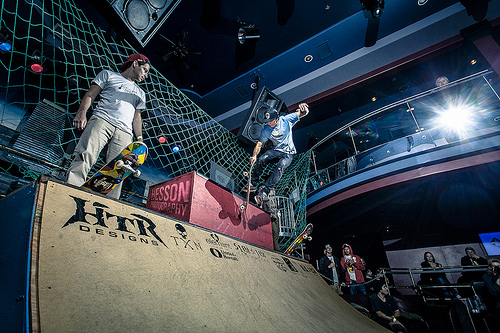<image>
Is the man above the ramp? Yes. The man is positioned above the ramp in the vertical space, higher up in the scene. 